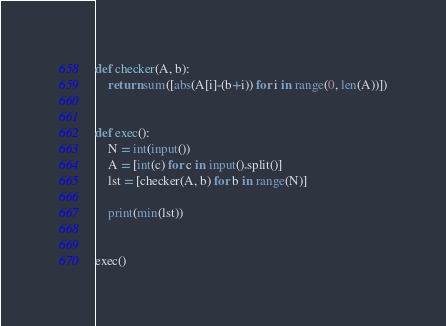<code> <loc_0><loc_0><loc_500><loc_500><_Python_>def checker(A, b):
    return sum([abs(A[i]-(b+i)) for i in range(0, len(A))])


def exec():
    N = int(input())
    A = [int(c) for c in input().split()]
    lst = [checker(A, b) for b in range(N)]

    print(min(lst))


exec()
</code> 